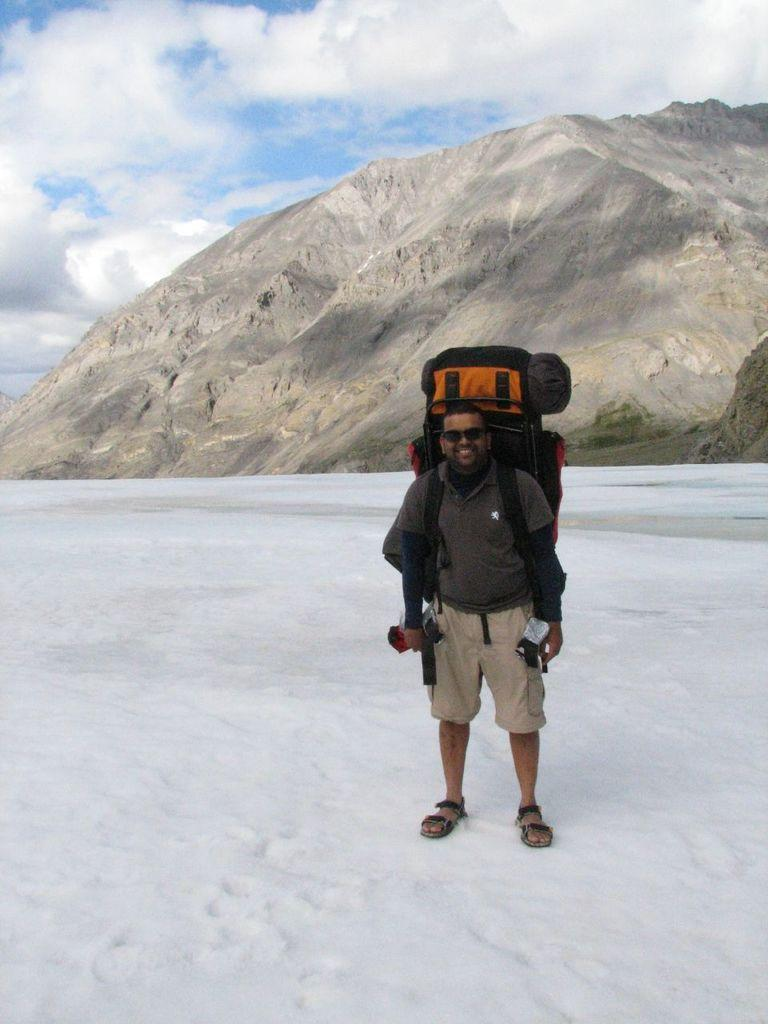What is the man in the image doing? The man is standing in the image. What is the man holding in the image? The man is holding a backpack in the image. Where is the man located in the image? The man is on a mountain in the image. What is the condition of the mountain in the image? The mountain is covered with snow in the image. How would you describe the sky in the image? The sky is blue and cloudy in the image. What type of pot is visible on the man's head in the image? There is no pot visible on the man's head in the image. What color is the bag hanging on the lamp in the image? There is no bag hanging on a lamp in the image. 